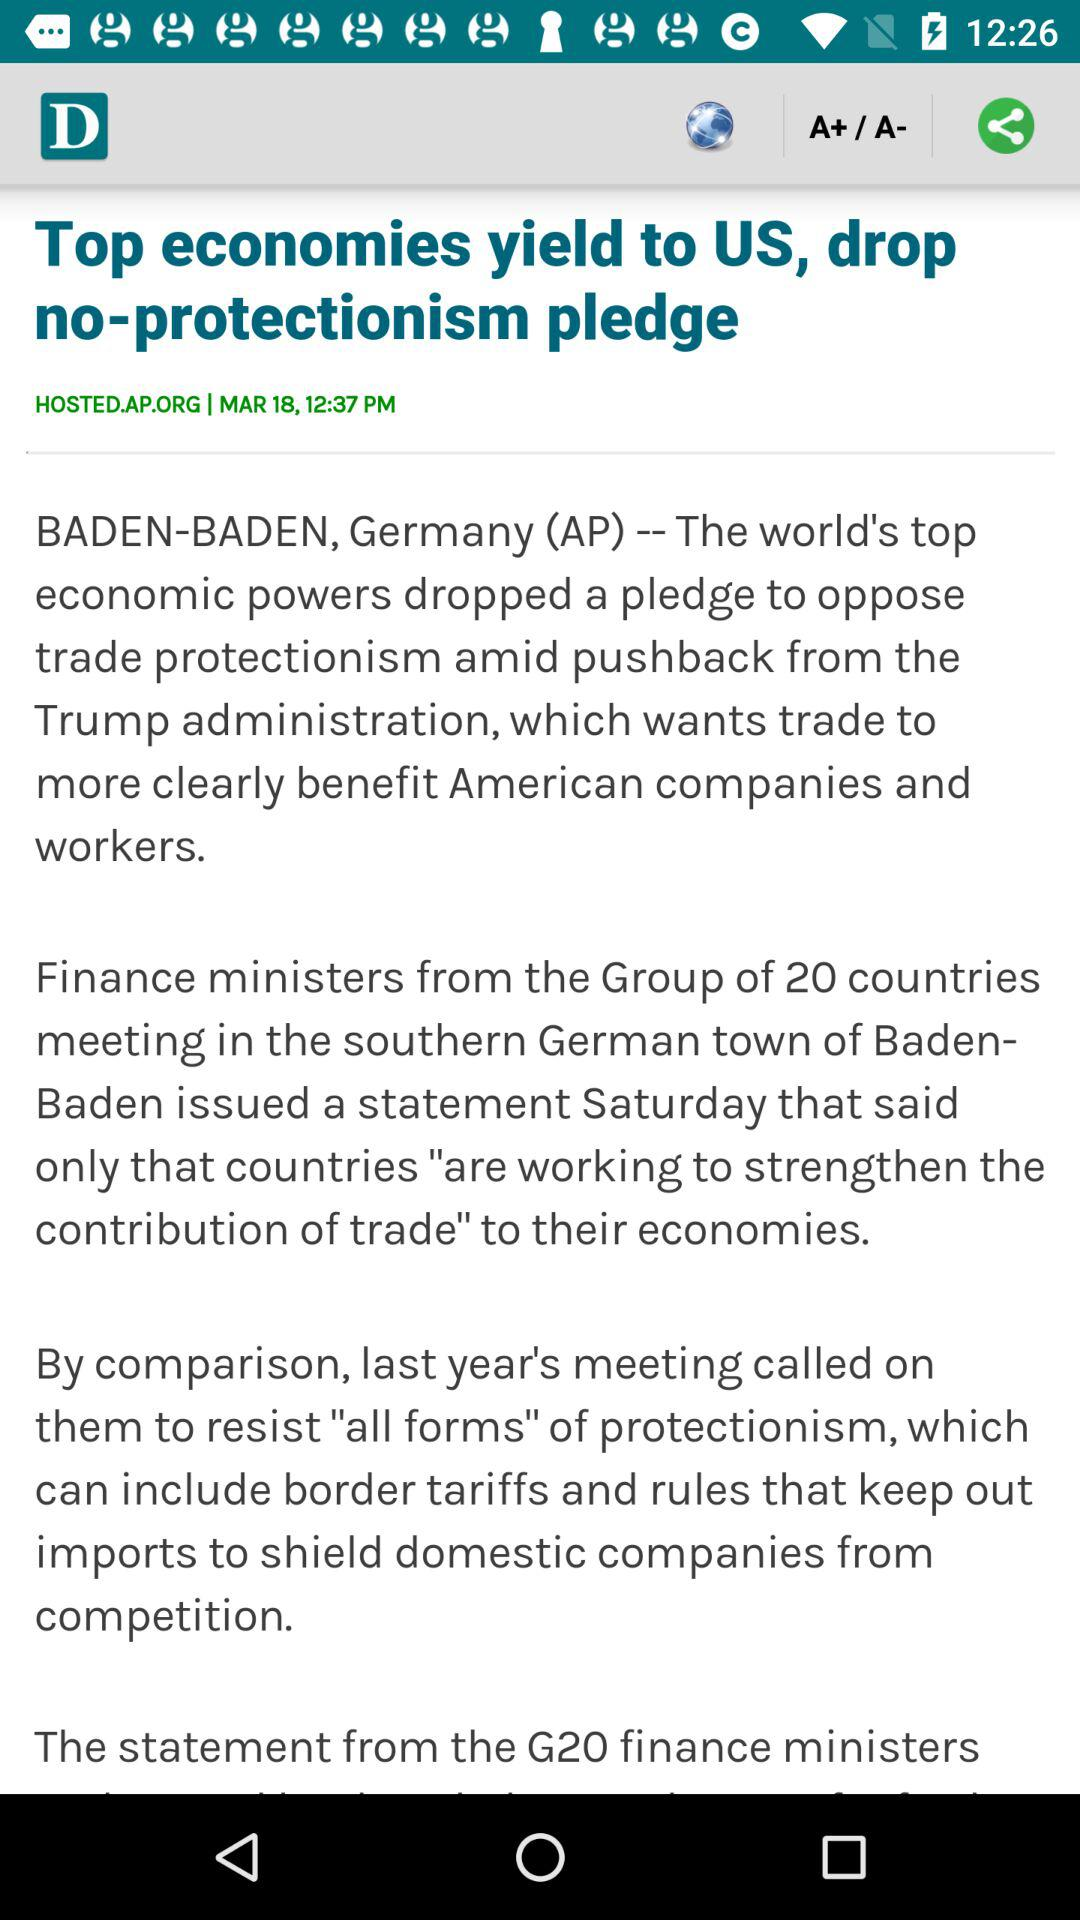What is the date? The date is March 18. 